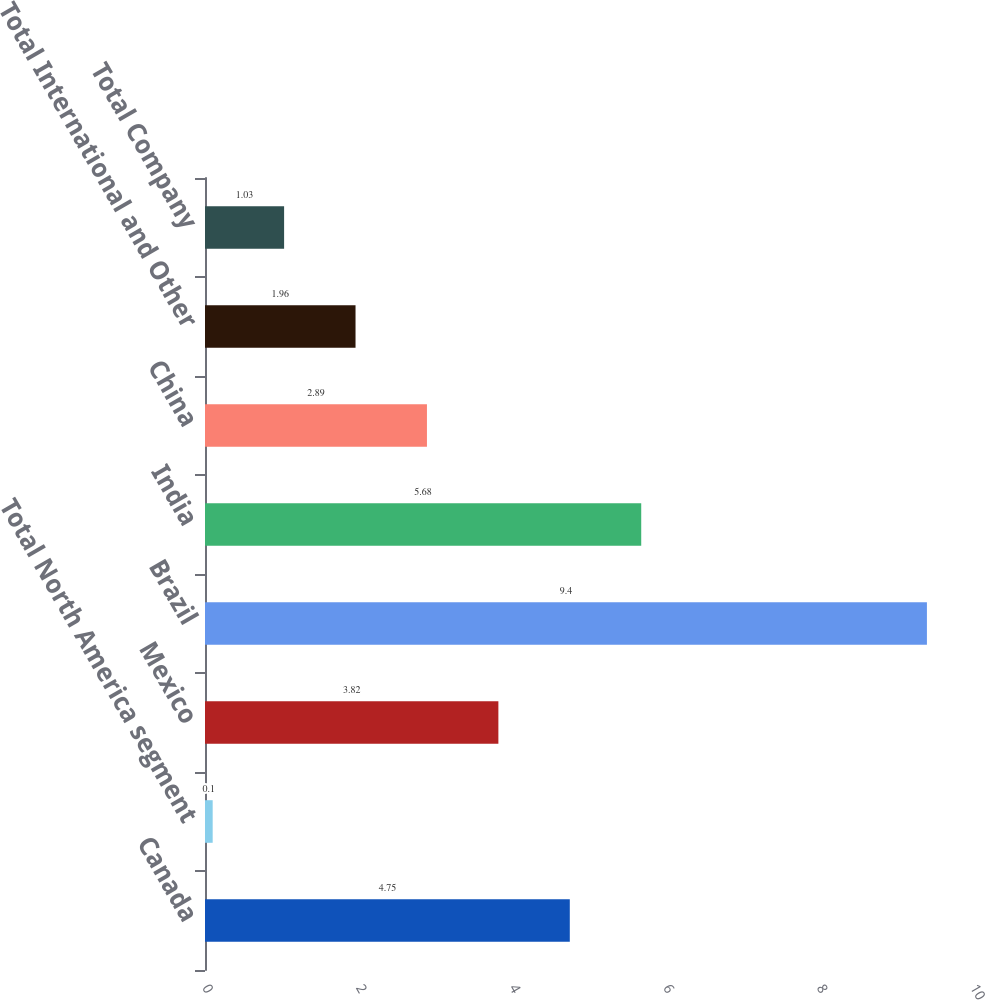Convert chart to OTSL. <chart><loc_0><loc_0><loc_500><loc_500><bar_chart><fcel>Canada<fcel>Total North America segment<fcel>Mexico<fcel>Brazil<fcel>India<fcel>China<fcel>Total International and Other<fcel>Total Company<nl><fcel>4.75<fcel>0.1<fcel>3.82<fcel>9.4<fcel>5.68<fcel>2.89<fcel>1.96<fcel>1.03<nl></chart> 